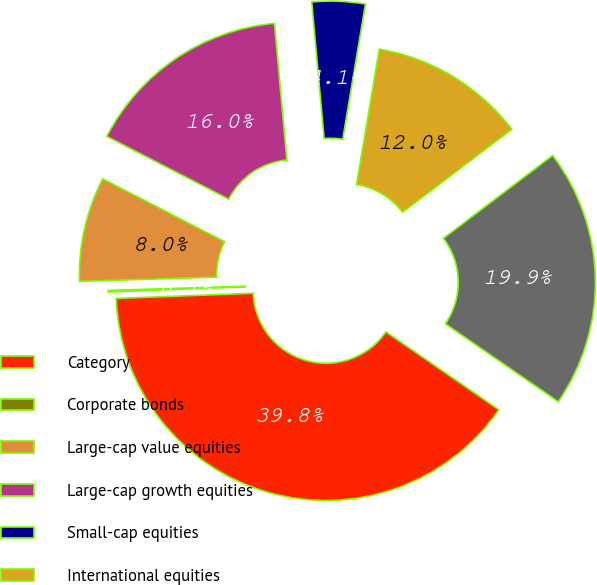Convert chart to OTSL. <chart><loc_0><loc_0><loc_500><loc_500><pie_chart><fcel>Category<fcel>Corporate bonds<fcel>Large-cap value equities<fcel>Large-cap growth equities<fcel>Small-cap equities<fcel>International equities<fcel>Total<nl><fcel>39.79%<fcel>0.12%<fcel>8.05%<fcel>15.99%<fcel>4.09%<fcel>12.02%<fcel>19.95%<nl></chart> 